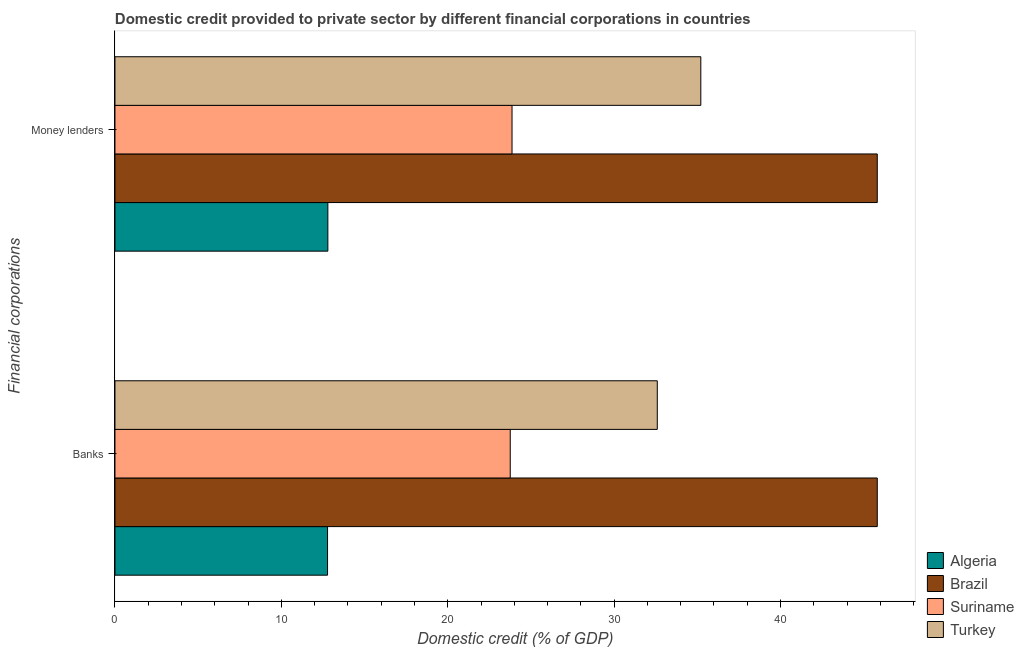How many different coloured bars are there?
Your answer should be very brief. 4. Are the number of bars per tick equal to the number of legend labels?
Your response must be concise. Yes. What is the label of the 2nd group of bars from the top?
Your answer should be very brief. Banks. What is the domestic credit provided by money lenders in Brazil?
Make the answer very short. 45.82. Across all countries, what is the maximum domestic credit provided by money lenders?
Your response must be concise. 45.82. Across all countries, what is the minimum domestic credit provided by money lenders?
Offer a very short reply. 12.8. In which country was the domestic credit provided by banks maximum?
Your answer should be compact. Brazil. In which country was the domestic credit provided by money lenders minimum?
Provide a short and direct response. Algeria. What is the total domestic credit provided by banks in the graph?
Offer a terse response. 114.94. What is the difference between the domestic credit provided by banks in Turkey and that in Algeria?
Offer a very short reply. 19.82. What is the difference between the domestic credit provided by money lenders in Brazil and the domestic credit provided by banks in Suriname?
Keep it short and to the point. 22.06. What is the average domestic credit provided by money lenders per country?
Offer a very short reply. 29.42. What is the difference between the domestic credit provided by banks and domestic credit provided by money lenders in Algeria?
Provide a succinct answer. -0.02. What is the ratio of the domestic credit provided by money lenders in Suriname to that in Turkey?
Give a very brief answer. 0.68. In how many countries, is the domestic credit provided by money lenders greater than the average domestic credit provided by money lenders taken over all countries?
Keep it short and to the point. 2. What does the 4th bar from the top in Banks represents?
Ensure brevity in your answer.  Algeria. How many bars are there?
Keep it short and to the point. 8. Where does the legend appear in the graph?
Your answer should be very brief. Bottom right. How many legend labels are there?
Your answer should be compact. 4. What is the title of the graph?
Ensure brevity in your answer.  Domestic credit provided to private sector by different financial corporations in countries. What is the label or title of the X-axis?
Ensure brevity in your answer.  Domestic credit (% of GDP). What is the label or title of the Y-axis?
Your answer should be compact. Financial corporations. What is the Domestic credit (% of GDP) of Algeria in Banks?
Keep it short and to the point. 12.78. What is the Domestic credit (% of GDP) of Brazil in Banks?
Offer a very short reply. 45.82. What is the Domestic credit (% of GDP) of Suriname in Banks?
Provide a short and direct response. 23.76. What is the Domestic credit (% of GDP) of Turkey in Banks?
Provide a succinct answer. 32.59. What is the Domestic credit (% of GDP) in Algeria in Money lenders?
Provide a succinct answer. 12.8. What is the Domestic credit (% of GDP) in Brazil in Money lenders?
Offer a terse response. 45.82. What is the Domestic credit (% of GDP) of Suriname in Money lenders?
Give a very brief answer. 23.86. What is the Domestic credit (% of GDP) of Turkey in Money lenders?
Make the answer very short. 35.21. Across all Financial corporations, what is the maximum Domestic credit (% of GDP) of Algeria?
Offer a very short reply. 12.8. Across all Financial corporations, what is the maximum Domestic credit (% of GDP) of Brazil?
Ensure brevity in your answer.  45.82. Across all Financial corporations, what is the maximum Domestic credit (% of GDP) in Suriname?
Ensure brevity in your answer.  23.86. Across all Financial corporations, what is the maximum Domestic credit (% of GDP) in Turkey?
Offer a terse response. 35.21. Across all Financial corporations, what is the minimum Domestic credit (% of GDP) in Algeria?
Provide a short and direct response. 12.78. Across all Financial corporations, what is the minimum Domestic credit (% of GDP) of Brazil?
Offer a very short reply. 45.82. Across all Financial corporations, what is the minimum Domestic credit (% of GDP) of Suriname?
Provide a succinct answer. 23.76. Across all Financial corporations, what is the minimum Domestic credit (% of GDP) in Turkey?
Your response must be concise. 32.59. What is the total Domestic credit (% of GDP) of Algeria in the graph?
Your answer should be very brief. 25.57. What is the total Domestic credit (% of GDP) of Brazil in the graph?
Ensure brevity in your answer.  91.63. What is the total Domestic credit (% of GDP) of Suriname in the graph?
Offer a terse response. 47.62. What is the total Domestic credit (% of GDP) of Turkey in the graph?
Keep it short and to the point. 67.8. What is the difference between the Domestic credit (% of GDP) in Algeria in Banks and that in Money lenders?
Your response must be concise. -0.02. What is the difference between the Domestic credit (% of GDP) of Suriname in Banks and that in Money lenders?
Offer a very short reply. -0.11. What is the difference between the Domestic credit (% of GDP) in Turkey in Banks and that in Money lenders?
Ensure brevity in your answer.  -2.62. What is the difference between the Domestic credit (% of GDP) of Algeria in Banks and the Domestic credit (% of GDP) of Brazil in Money lenders?
Your response must be concise. -33.04. What is the difference between the Domestic credit (% of GDP) in Algeria in Banks and the Domestic credit (% of GDP) in Suriname in Money lenders?
Give a very brief answer. -11.09. What is the difference between the Domestic credit (% of GDP) in Algeria in Banks and the Domestic credit (% of GDP) in Turkey in Money lenders?
Your answer should be very brief. -22.43. What is the difference between the Domestic credit (% of GDP) in Brazil in Banks and the Domestic credit (% of GDP) in Suriname in Money lenders?
Ensure brevity in your answer.  21.95. What is the difference between the Domestic credit (% of GDP) in Brazil in Banks and the Domestic credit (% of GDP) in Turkey in Money lenders?
Your answer should be very brief. 10.61. What is the difference between the Domestic credit (% of GDP) in Suriname in Banks and the Domestic credit (% of GDP) in Turkey in Money lenders?
Ensure brevity in your answer.  -11.45. What is the average Domestic credit (% of GDP) of Algeria per Financial corporations?
Keep it short and to the point. 12.79. What is the average Domestic credit (% of GDP) in Brazil per Financial corporations?
Your response must be concise. 45.82. What is the average Domestic credit (% of GDP) of Suriname per Financial corporations?
Make the answer very short. 23.81. What is the average Domestic credit (% of GDP) in Turkey per Financial corporations?
Your answer should be compact. 33.9. What is the difference between the Domestic credit (% of GDP) of Algeria and Domestic credit (% of GDP) of Brazil in Banks?
Your response must be concise. -33.04. What is the difference between the Domestic credit (% of GDP) in Algeria and Domestic credit (% of GDP) in Suriname in Banks?
Keep it short and to the point. -10.98. What is the difference between the Domestic credit (% of GDP) of Algeria and Domestic credit (% of GDP) of Turkey in Banks?
Offer a very short reply. -19.82. What is the difference between the Domestic credit (% of GDP) in Brazil and Domestic credit (% of GDP) in Suriname in Banks?
Offer a terse response. 22.06. What is the difference between the Domestic credit (% of GDP) in Brazil and Domestic credit (% of GDP) in Turkey in Banks?
Offer a very short reply. 13.22. What is the difference between the Domestic credit (% of GDP) of Suriname and Domestic credit (% of GDP) of Turkey in Banks?
Your answer should be compact. -8.84. What is the difference between the Domestic credit (% of GDP) of Algeria and Domestic credit (% of GDP) of Brazil in Money lenders?
Your answer should be compact. -33.02. What is the difference between the Domestic credit (% of GDP) in Algeria and Domestic credit (% of GDP) in Suriname in Money lenders?
Your answer should be compact. -11.07. What is the difference between the Domestic credit (% of GDP) of Algeria and Domestic credit (% of GDP) of Turkey in Money lenders?
Offer a very short reply. -22.41. What is the difference between the Domestic credit (% of GDP) of Brazil and Domestic credit (% of GDP) of Suriname in Money lenders?
Your answer should be compact. 21.95. What is the difference between the Domestic credit (% of GDP) in Brazil and Domestic credit (% of GDP) in Turkey in Money lenders?
Provide a short and direct response. 10.61. What is the difference between the Domestic credit (% of GDP) of Suriname and Domestic credit (% of GDP) of Turkey in Money lenders?
Your answer should be very brief. -11.35. What is the ratio of the Domestic credit (% of GDP) in Turkey in Banks to that in Money lenders?
Your response must be concise. 0.93. What is the difference between the highest and the second highest Domestic credit (% of GDP) in Algeria?
Provide a succinct answer. 0.02. What is the difference between the highest and the second highest Domestic credit (% of GDP) of Brazil?
Offer a very short reply. 0. What is the difference between the highest and the second highest Domestic credit (% of GDP) in Suriname?
Give a very brief answer. 0.11. What is the difference between the highest and the second highest Domestic credit (% of GDP) in Turkey?
Ensure brevity in your answer.  2.62. What is the difference between the highest and the lowest Domestic credit (% of GDP) in Algeria?
Provide a short and direct response. 0.02. What is the difference between the highest and the lowest Domestic credit (% of GDP) in Suriname?
Provide a succinct answer. 0.11. What is the difference between the highest and the lowest Domestic credit (% of GDP) in Turkey?
Your response must be concise. 2.62. 